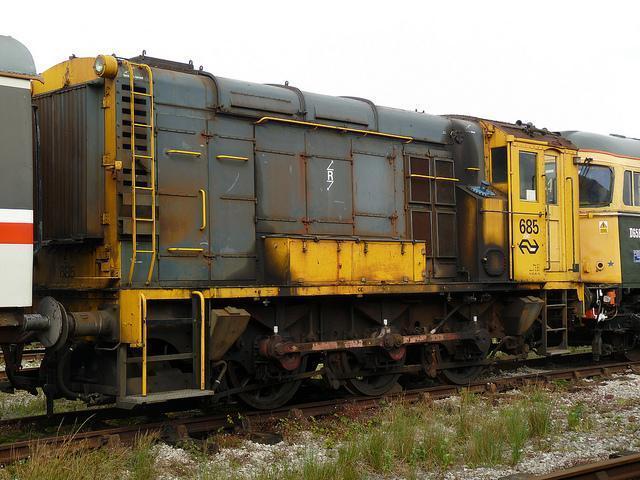How many orange boats are there?
Give a very brief answer. 0. 